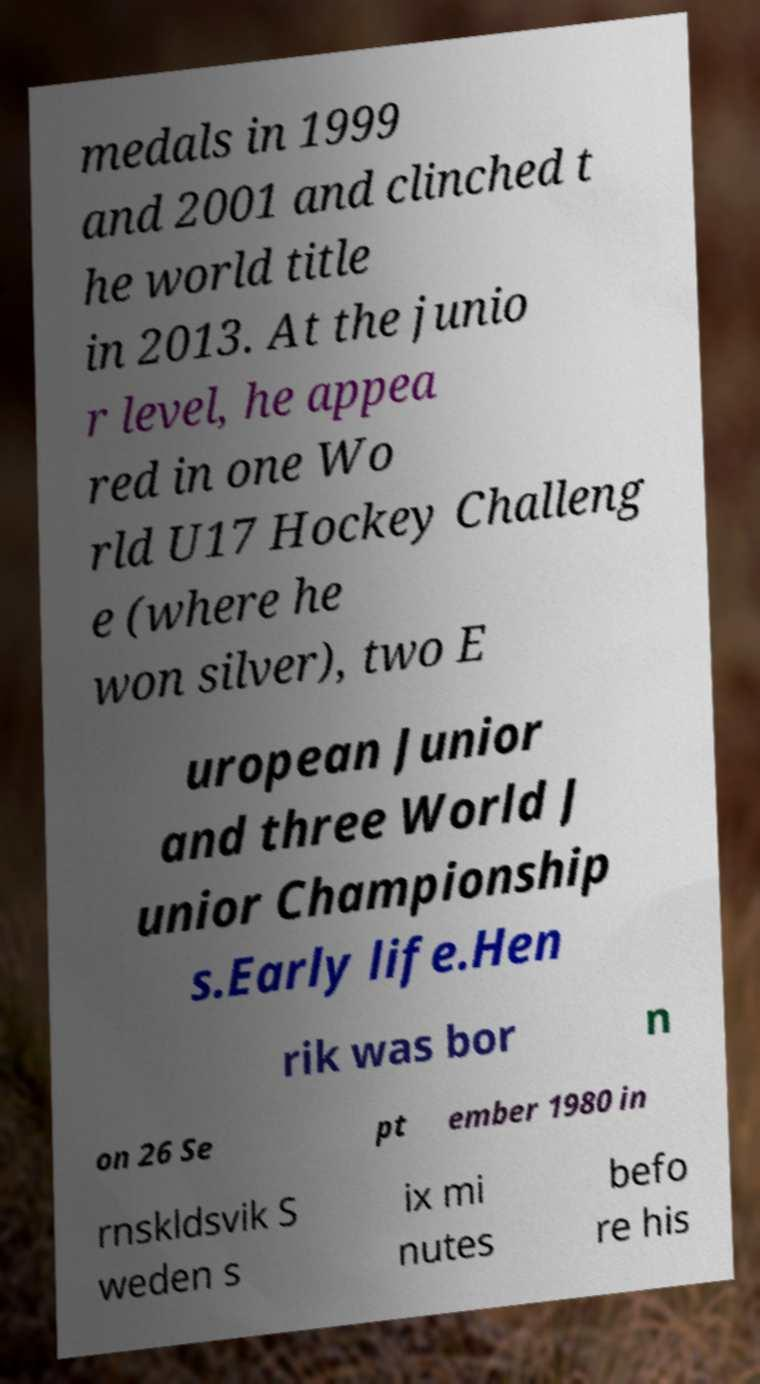Please identify and transcribe the text found in this image. medals in 1999 and 2001 and clinched t he world title in 2013. At the junio r level, he appea red in one Wo rld U17 Hockey Challeng e (where he won silver), two E uropean Junior and three World J unior Championship s.Early life.Hen rik was bor n on 26 Se pt ember 1980 in rnskldsvik S weden s ix mi nutes befo re his 